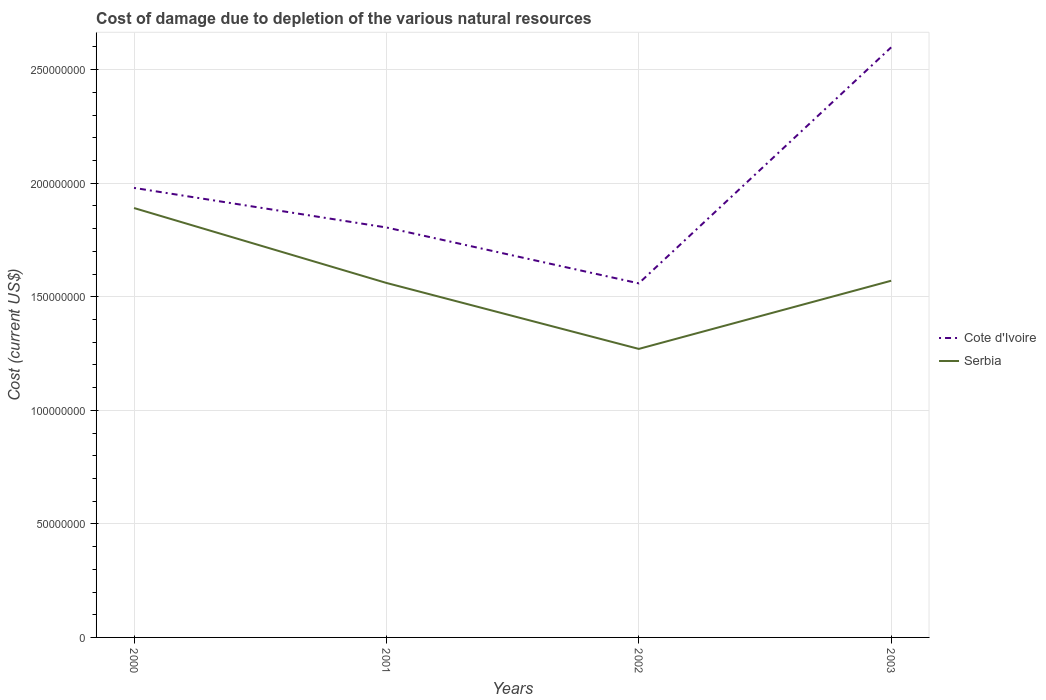How many different coloured lines are there?
Provide a short and direct response. 2. Across all years, what is the maximum cost of damage caused due to the depletion of various natural resources in Cote d'Ivoire?
Offer a very short reply. 1.56e+08. What is the total cost of damage caused due to the depletion of various natural resources in Serbia in the graph?
Provide a short and direct response. 3.30e+07. What is the difference between the highest and the second highest cost of damage caused due to the depletion of various natural resources in Cote d'Ivoire?
Your answer should be compact. 1.04e+08. What is the difference between the highest and the lowest cost of damage caused due to the depletion of various natural resources in Cote d'Ivoire?
Provide a succinct answer. 1. Is the cost of damage caused due to the depletion of various natural resources in Serbia strictly greater than the cost of damage caused due to the depletion of various natural resources in Cote d'Ivoire over the years?
Give a very brief answer. Yes. How many lines are there?
Give a very brief answer. 2. What is the difference between two consecutive major ticks on the Y-axis?
Your response must be concise. 5.00e+07. Where does the legend appear in the graph?
Offer a terse response. Center right. How many legend labels are there?
Offer a terse response. 2. How are the legend labels stacked?
Offer a very short reply. Vertical. What is the title of the graph?
Provide a short and direct response. Cost of damage due to depletion of the various natural resources. What is the label or title of the X-axis?
Offer a very short reply. Years. What is the label or title of the Y-axis?
Your answer should be very brief. Cost (current US$). What is the Cost (current US$) of Cote d'Ivoire in 2000?
Provide a short and direct response. 1.98e+08. What is the Cost (current US$) of Serbia in 2000?
Your response must be concise. 1.89e+08. What is the Cost (current US$) in Cote d'Ivoire in 2001?
Your answer should be very brief. 1.81e+08. What is the Cost (current US$) of Serbia in 2001?
Offer a terse response. 1.56e+08. What is the Cost (current US$) in Cote d'Ivoire in 2002?
Your response must be concise. 1.56e+08. What is the Cost (current US$) of Serbia in 2002?
Offer a terse response. 1.27e+08. What is the Cost (current US$) in Cote d'Ivoire in 2003?
Make the answer very short. 2.60e+08. What is the Cost (current US$) of Serbia in 2003?
Provide a succinct answer. 1.57e+08. Across all years, what is the maximum Cost (current US$) of Cote d'Ivoire?
Provide a short and direct response. 2.60e+08. Across all years, what is the maximum Cost (current US$) of Serbia?
Your answer should be very brief. 1.89e+08. Across all years, what is the minimum Cost (current US$) of Cote d'Ivoire?
Your answer should be compact. 1.56e+08. Across all years, what is the minimum Cost (current US$) of Serbia?
Your answer should be compact. 1.27e+08. What is the total Cost (current US$) of Cote d'Ivoire in the graph?
Give a very brief answer. 7.94e+08. What is the total Cost (current US$) in Serbia in the graph?
Offer a very short reply. 6.29e+08. What is the difference between the Cost (current US$) of Cote d'Ivoire in 2000 and that in 2001?
Give a very brief answer. 1.74e+07. What is the difference between the Cost (current US$) in Serbia in 2000 and that in 2001?
Offer a terse response. 3.30e+07. What is the difference between the Cost (current US$) in Cote d'Ivoire in 2000 and that in 2002?
Ensure brevity in your answer.  4.20e+07. What is the difference between the Cost (current US$) in Serbia in 2000 and that in 2002?
Make the answer very short. 6.20e+07. What is the difference between the Cost (current US$) of Cote d'Ivoire in 2000 and that in 2003?
Offer a very short reply. -6.19e+07. What is the difference between the Cost (current US$) in Serbia in 2000 and that in 2003?
Keep it short and to the point. 3.20e+07. What is the difference between the Cost (current US$) of Cote d'Ivoire in 2001 and that in 2002?
Make the answer very short. 2.46e+07. What is the difference between the Cost (current US$) in Serbia in 2001 and that in 2002?
Give a very brief answer. 2.91e+07. What is the difference between the Cost (current US$) in Cote d'Ivoire in 2001 and that in 2003?
Keep it short and to the point. -7.93e+07. What is the difference between the Cost (current US$) in Serbia in 2001 and that in 2003?
Keep it short and to the point. -9.69e+05. What is the difference between the Cost (current US$) of Cote d'Ivoire in 2002 and that in 2003?
Provide a succinct answer. -1.04e+08. What is the difference between the Cost (current US$) of Serbia in 2002 and that in 2003?
Provide a succinct answer. -3.00e+07. What is the difference between the Cost (current US$) of Cote d'Ivoire in 2000 and the Cost (current US$) of Serbia in 2001?
Give a very brief answer. 4.18e+07. What is the difference between the Cost (current US$) in Cote d'Ivoire in 2000 and the Cost (current US$) in Serbia in 2002?
Your answer should be compact. 7.09e+07. What is the difference between the Cost (current US$) in Cote d'Ivoire in 2000 and the Cost (current US$) in Serbia in 2003?
Offer a terse response. 4.09e+07. What is the difference between the Cost (current US$) of Cote d'Ivoire in 2001 and the Cost (current US$) of Serbia in 2002?
Keep it short and to the point. 5.35e+07. What is the difference between the Cost (current US$) of Cote d'Ivoire in 2001 and the Cost (current US$) of Serbia in 2003?
Your answer should be very brief. 2.35e+07. What is the difference between the Cost (current US$) in Cote d'Ivoire in 2002 and the Cost (current US$) in Serbia in 2003?
Ensure brevity in your answer.  -1.15e+06. What is the average Cost (current US$) in Cote d'Ivoire per year?
Your answer should be very brief. 1.99e+08. What is the average Cost (current US$) of Serbia per year?
Ensure brevity in your answer.  1.57e+08. In the year 2000, what is the difference between the Cost (current US$) in Cote d'Ivoire and Cost (current US$) in Serbia?
Make the answer very short. 8.87e+06. In the year 2001, what is the difference between the Cost (current US$) in Cote d'Ivoire and Cost (current US$) in Serbia?
Ensure brevity in your answer.  2.44e+07. In the year 2002, what is the difference between the Cost (current US$) in Cote d'Ivoire and Cost (current US$) in Serbia?
Your answer should be compact. 2.89e+07. In the year 2003, what is the difference between the Cost (current US$) of Cote d'Ivoire and Cost (current US$) of Serbia?
Your response must be concise. 1.03e+08. What is the ratio of the Cost (current US$) of Cote d'Ivoire in 2000 to that in 2001?
Your response must be concise. 1.1. What is the ratio of the Cost (current US$) of Serbia in 2000 to that in 2001?
Ensure brevity in your answer.  1.21. What is the ratio of the Cost (current US$) of Cote d'Ivoire in 2000 to that in 2002?
Your response must be concise. 1.27. What is the ratio of the Cost (current US$) in Serbia in 2000 to that in 2002?
Offer a very short reply. 1.49. What is the ratio of the Cost (current US$) in Cote d'Ivoire in 2000 to that in 2003?
Ensure brevity in your answer.  0.76. What is the ratio of the Cost (current US$) in Serbia in 2000 to that in 2003?
Your answer should be very brief. 1.2. What is the ratio of the Cost (current US$) in Cote d'Ivoire in 2001 to that in 2002?
Offer a terse response. 1.16. What is the ratio of the Cost (current US$) in Serbia in 2001 to that in 2002?
Your answer should be compact. 1.23. What is the ratio of the Cost (current US$) of Cote d'Ivoire in 2001 to that in 2003?
Your response must be concise. 0.69. What is the ratio of the Cost (current US$) in Cote d'Ivoire in 2002 to that in 2003?
Your response must be concise. 0.6. What is the ratio of the Cost (current US$) of Serbia in 2002 to that in 2003?
Give a very brief answer. 0.81. What is the difference between the highest and the second highest Cost (current US$) in Cote d'Ivoire?
Your answer should be very brief. 6.19e+07. What is the difference between the highest and the second highest Cost (current US$) in Serbia?
Offer a very short reply. 3.20e+07. What is the difference between the highest and the lowest Cost (current US$) in Cote d'Ivoire?
Your response must be concise. 1.04e+08. What is the difference between the highest and the lowest Cost (current US$) in Serbia?
Offer a terse response. 6.20e+07. 